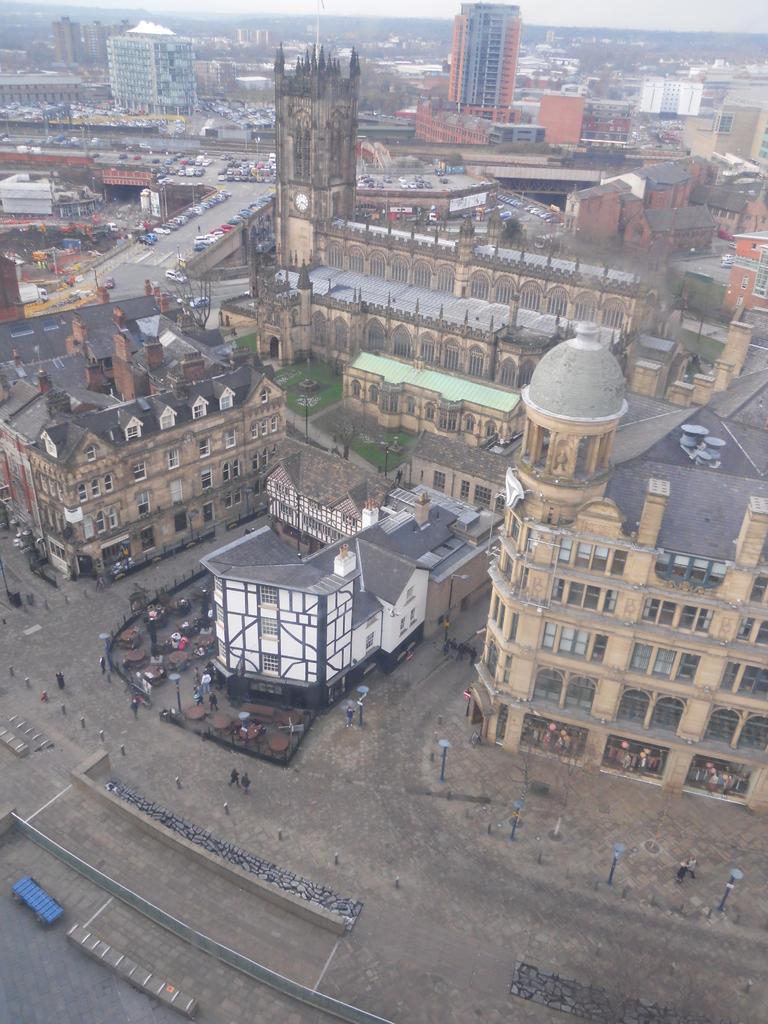In one or two sentences, can you explain what this image depicts? In this image, I can see the view of the city. These are the buildings. I can see the vehicles on the roads. There are few people standing. I think these are the street lights. 